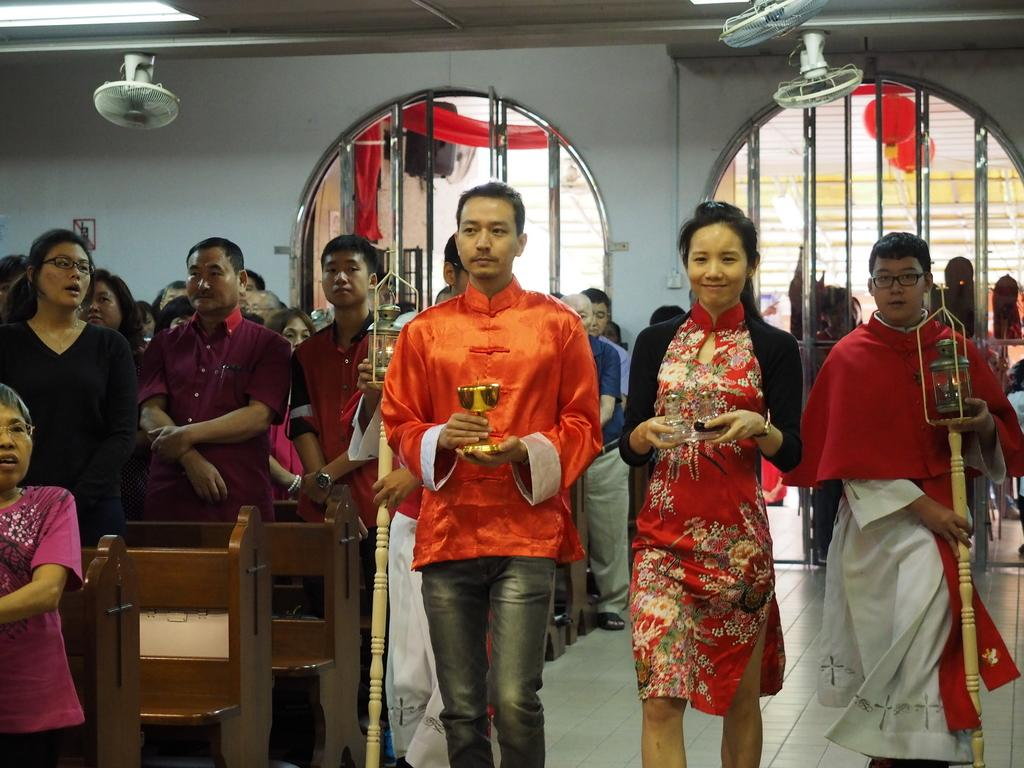How many people are in the group in the image? There is a group of people in the image, but the exact number is not specified. What are some people in the group holding? Some people in the group are holding objects, but the specific objects are not mentioned. What can be seen in the background of the image? There is a wall in the background of the image. What features does the wall have? The wall has doors and fans. What type of fog can be seen in the image? There is no fog present in the image; it features a group of people, a wall with doors and fans, and some people holding objects. 